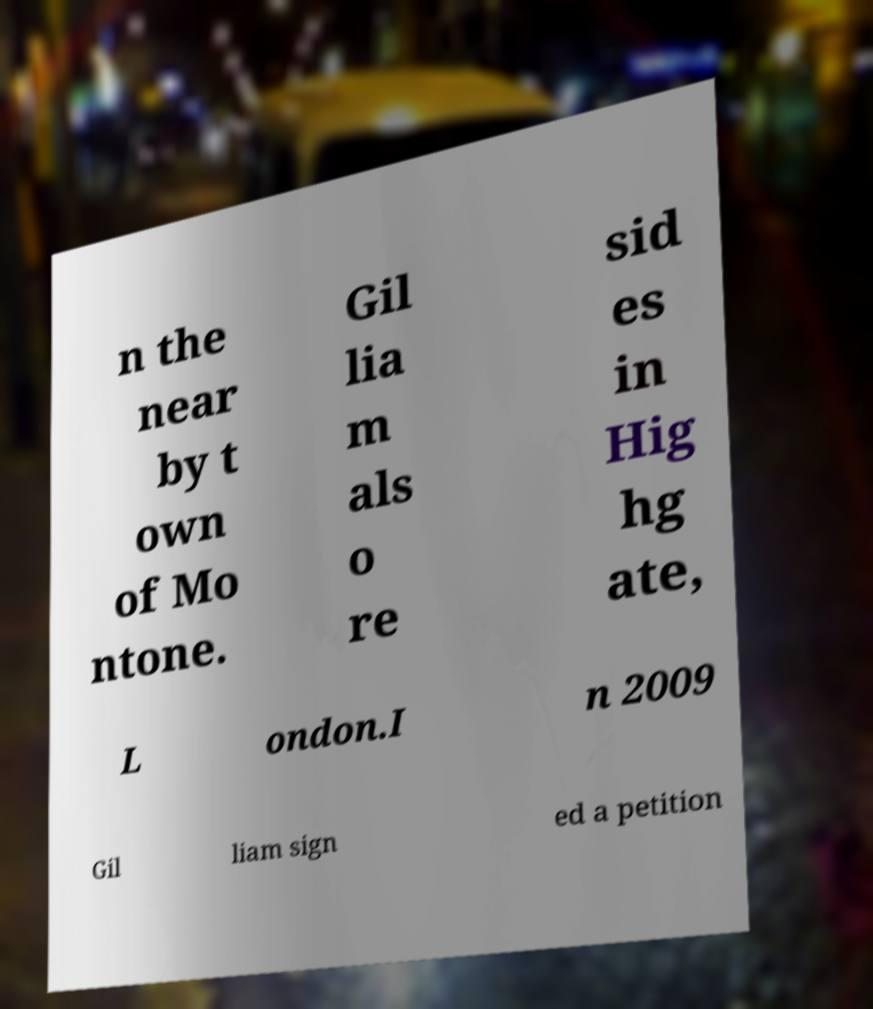Could you extract and type out the text from this image? n the near by t own of Mo ntone. Gil lia m als o re sid es in Hig hg ate, L ondon.I n 2009 Gil liam sign ed a petition 